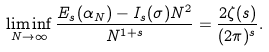Convert formula to latex. <formula><loc_0><loc_0><loc_500><loc_500>\liminf _ { N \rightarrow \infty } \frac { E _ { s } ( \alpha _ { N } ) - I _ { s } ( \sigma ) N ^ { 2 } } { N ^ { 1 + s } } = \frac { 2 \zeta ( s ) } { ( 2 \pi ) ^ { s } } .</formula> 